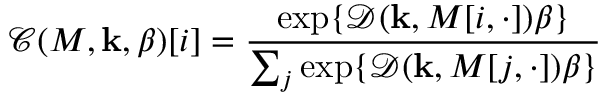Convert formula to latex. <formula><loc_0><loc_0><loc_500><loc_500>{ \mathcal { C } } ( M , k , \beta ) [ i ] = { \frac { \exp \{ { \mathcal { D } } ( k , M [ i , \cdot ] ) \beta \} } { \sum _ { j } \exp \{ { \mathcal { D } } ( k , M [ j , \cdot ] ) \beta \} } }</formula> 